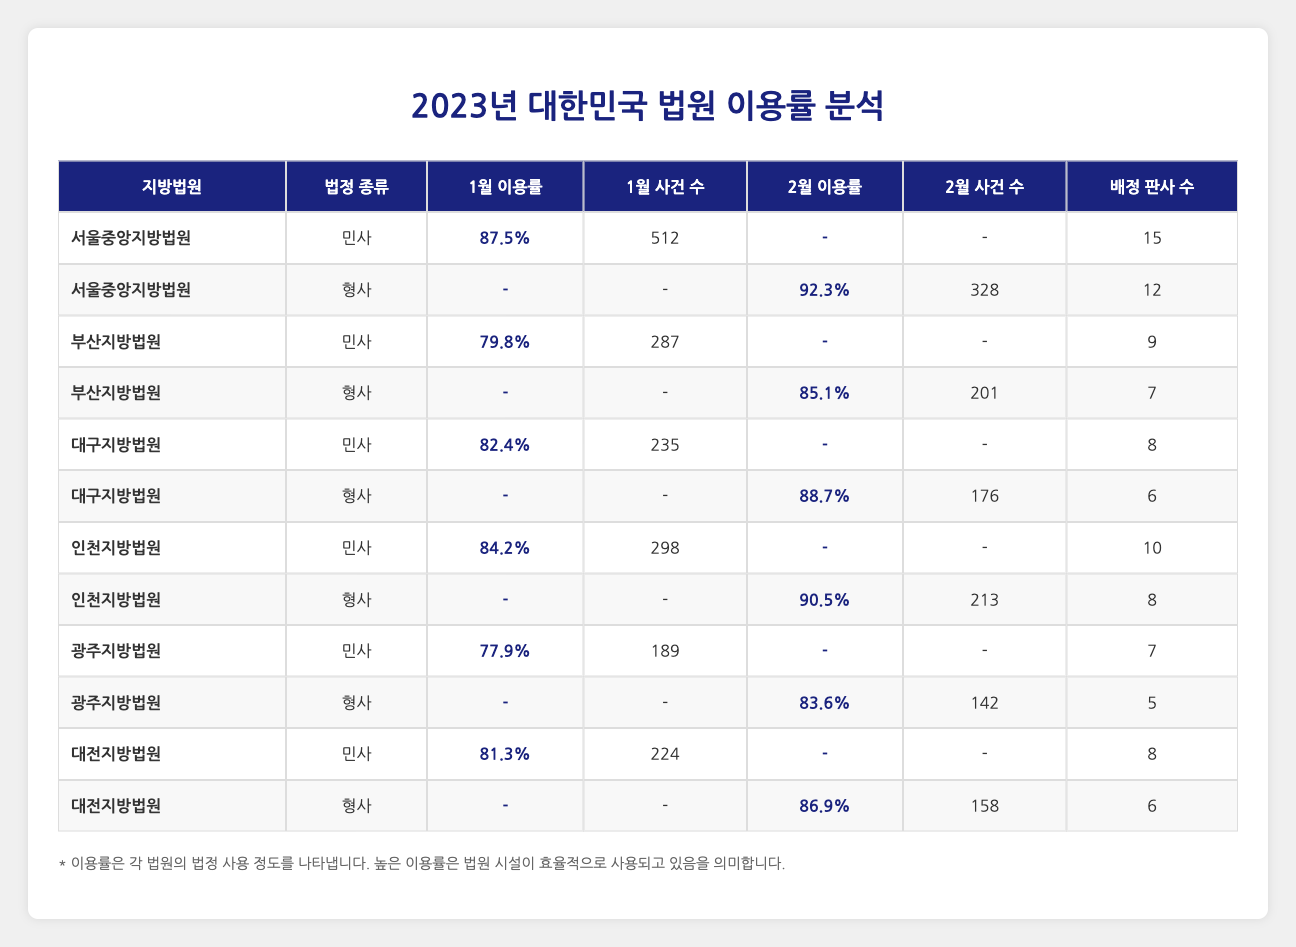What is the utilization rate for the Civil Court at the Seoul Central District Court in January 2023? The table shows that the utilization rate for the Civil Court at the Seoul Central District Court in January 2023 is 87.5%.
Answer: 87.5% Which district had the highest utilization rate for the Criminal Court in February 2023? By reviewing the February 2023 data, the Incheon District Court shows the highest utilization rate of 90.5% for the Criminal Court.
Answer: Incheon District Court Is the utilization rate for the Civil Court at the Daegu District Court higher than that at the Busan District Court in January 2023? The utilization rate for the Civil Court at the Daegu District Court is 82.4%, while for Busan it is 79.8%. Since 82.4% is greater than 79.8%, the answer is yes.
Answer: Yes What is the average utilization rate of the Criminal Courts across all districts in February 2023? The utilization rates for Criminal Courts in February 2023 are as follows: Seoul (92.3%), Busan (85.1%), Daegu (88.7%), Incheon (90.5%), Gwangju (83.6%), and Daejeon (86.9%). Summing these values gives (92.3 + 85.1 + 88.7 + 90.5 + 83.6 + 86.9) = 526.1. There are 6 data points, so the average is 526.1 / 6 ≈ 87.68.
Answer: 87.68 Did any district have a Criminal Court utilization rate of less than 80% in February 2023? From the table, the lowest Criminal Court utilization rate in February is 83.6% for Gwangju District Court. Since all rates are above 80%, the answer is no.
Answer: No 